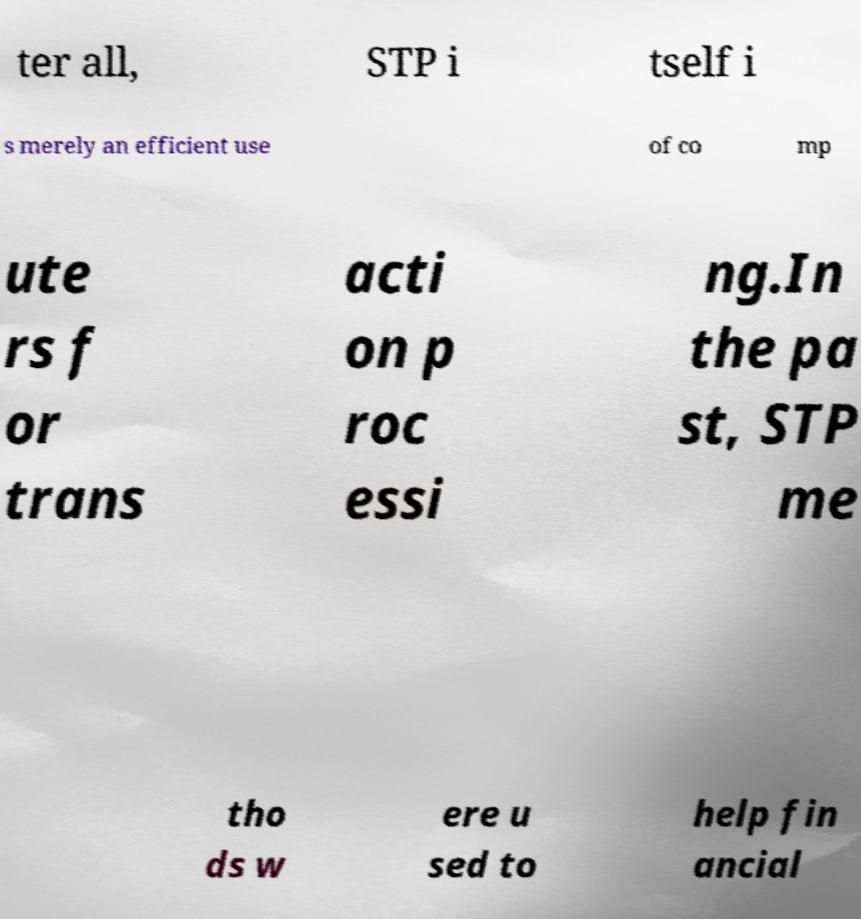For documentation purposes, I need the text within this image transcribed. Could you provide that? ter all, STP i tself i s merely an efficient use of co mp ute rs f or trans acti on p roc essi ng.In the pa st, STP me tho ds w ere u sed to help fin ancial 